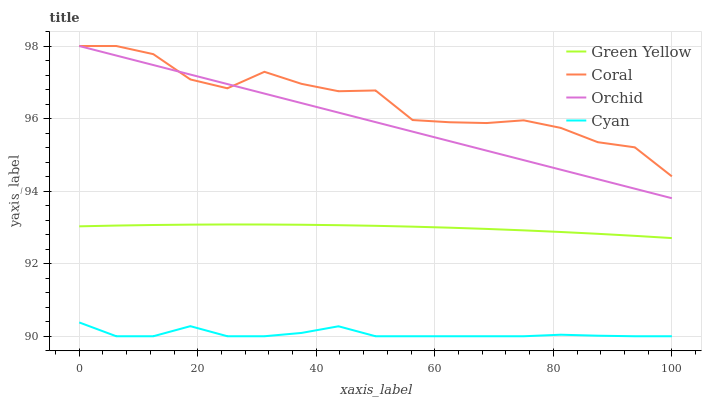Does Cyan have the minimum area under the curve?
Answer yes or no. Yes. Does Coral have the maximum area under the curve?
Answer yes or no. Yes. Does Green Yellow have the minimum area under the curve?
Answer yes or no. No. Does Green Yellow have the maximum area under the curve?
Answer yes or no. No. Is Orchid the smoothest?
Answer yes or no. Yes. Is Coral the roughest?
Answer yes or no. Yes. Is Green Yellow the smoothest?
Answer yes or no. No. Is Green Yellow the roughest?
Answer yes or no. No. Does Cyan have the lowest value?
Answer yes or no. Yes. Does Green Yellow have the lowest value?
Answer yes or no. No. Does Orchid have the highest value?
Answer yes or no. Yes. Does Green Yellow have the highest value?
Answer yes or no. No. Is Green Yellow less than Coral?
Answer yes or no. Yes. Is Coral greater than Cyan?
Answer yes or no. Yes. Does Orchid intersect Coral?
Answer yes or no. Yes. Is Orchid less than Coral?
Answer yes or no. No. Is Orchid greater than Coral?
Answer yes or no. No. Does Green Yellow intersect Coral?
Answer yes or no. No. 